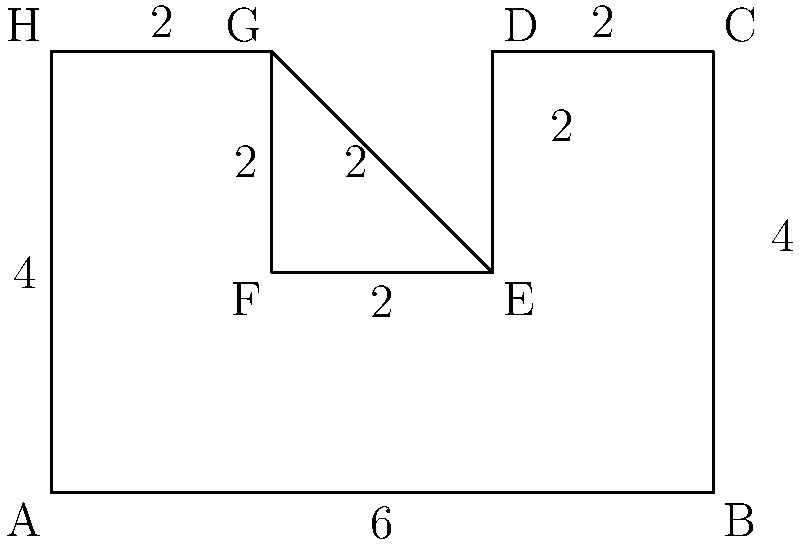In the given complex shape, calculate its perimeter. All measurements are in meters, and the shape is composed of rectangles. Remember to approach this methodically and stay composed while breaking down the problem into manageable steps. Let's break this down step-by-step:

1) First, let's identify the outer edges of the shape:
   - Bottom edge: AB = 6m
   - Right edge: BC = 4m
   - Top edge (split into three parts): CD + FG + GH = 2m + 2m + 2m = 6m
   - Left edge: HA = 4m

2) Now, let's add the inner edges that contribute to the perimeter:
   - DE = 2m
   - EF = 2m

3) Sum up all these lengths:
   $$ \text{Perimeter} = AB + BC + CD + DE + EF + FG + GH + HA $$
   $$ = 6 + 4 + 2 + 2 + 2 + 2 + 2 + 4 $$
   $$ = 24 \text{ meters} $$

By calmly breaking down the shape into its component parts and methodically adding up the lengths, we arrive at the total perimeter.
Answer: 24 meters 